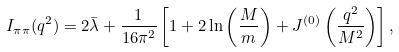Convert formula to latex. <formula><loc_0><loc_0><loc_500><loc_500>I _ { \pi \pi } ( q ^ { 2 } ) = 2 \bar { \lambda } + \frac { 1 } { 1 6 \pi ^ { 2 } } \left [ 1 + 2 \ln \left ( \frac { M } { m } \right ) + J ^ { ( 0 ) } \left ( \frac { q ^ { 2 } } { M ^ { 2 } } \right ) \right ] ,</formula> 